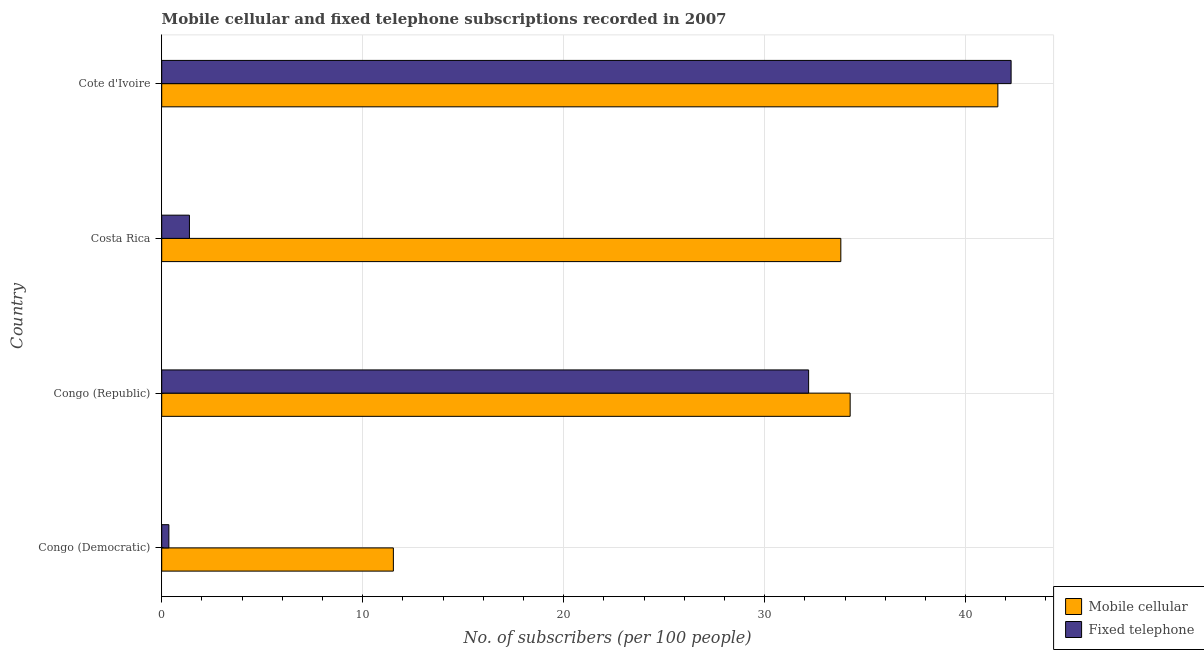How many different coloured bars are there?
Make the answer very short. 2. How many bars are there on the 3rd tick from the top?
Offer a terse response. 2. How many bars are there on the 4th tick from the bottom?
Provide a succinct answer. 2. What is the label of the 3rd group of bars from the top?
Your answer should be very brief. Congo (Republic). In how many cases, is the number of bars for a given country not equal to the number of legend labels?
Your answer should be compact. 0. What is the number of mobile cellular subscribers in Cote d'Ivoire?
Make the answer very short. 41.61. Across all countries, what is the maximum number of mobile cellular subscribers?
Make the answer very short. 41.61. Across all countries, what is the minimum number of mobile cellular subscribers?
Give a very brief answer. 11.53. In which country was the number of mobile cellular subscribers maximum?
Provide a succinct answer. Cote d'Ivoire. In which country was the number of mobile cellular subscribers minimum?
Your response must be concise. Congo (Democratic). What is the total number of fixed telephone subscribers in the graph?
Your answer should be compact. 76.19. What is the difference between the number of fixed telephone subscribers in Congo (Republic) and that in Costa Rica?
Provide a short and direct response. 30.81. What is the difference between the number of fixed telephone subscribers in Costa Rica and the number of mobile cellular subscribers in Cote d'Ivoire?
Ensure brevity in your answer.  -40.23. What is the average number of fixed telephone subscribers per country?
Your answer should be very brief. 19.05. What is the difference between the number of mobile cellular subscribers and number of fixed telephone subscribers in Cote d'Ivoire?
Your answer should be very brief. -0.66. What is the ratio of the number of mobile cellular subscribers in Congo (Republic) to that in Cote d'Ivoire?
Give a very brief answer. 0.82. Is the number of mobile cellular subscribers in Congo (Democratic) less than that in Costa Rica?
Give a very brief answer. Yes. Is the difference between the number of mobile cellular subscribers in Congo (Democratic) and Cote d'Ivoire greater than the difference between the number of fixed telephone subscribers in Congo (Democratic) and Cote d'Ivoire?
Provide a short and direct response. Yes. What is the difference between the highest and the second highest number of fixed telephone subscribers?
Your answer should be very brief. 10.07. What is the difference between the highest and the lowest number of mobile cellular subscribers?
Offer a terse response. 30.08. In how many countries, is the number of fixed telephone subscribers greater than the average number of fixed telephone subscribers taken over all countries?
Keep it short and to the point. 2. Is the sum of the number of fixed telephone subscribers in Costa Rica and Cote d'Ivoire greater than the maximum number of mobile cellular subscribers across all countries?
Offer a very short reply. Yes. What does the 1st bar from the top in Congo (Democratic) represents?
Offer a very short reply. Fixed telephone. What does the 2nd bar from the bottom in Congo (Democratic) represents?
Your answer should be compact. Fixed telephone. How many bars are there?
Give a very brief answer. 8. Are all the bars in the graph horizontal?
Give a very brief answer. Yes. What is the title of the graph?
Your answer should be compact. Mobile cellular and fixed telephone subscriptions recorded in 2007. Does "Investment in Telecom" appear as one of the legend labels in the graph?
Your response must be concise. No. What is the label or title of the X-axis?
Your answer should be compact. No. of subscribers (per 100 people). What is the label or title of the Y-axis?
Your response must be concise. Country. What is the No. of subscribers (per 100 people) of Mobile cellular in Congo (Democratic)?
Give a very brief answer. 11.53. What is the No. of subscribers (per 100 people) in Fixed telephone in Congo (Democratic)?
Make the answer very short. 0.36. What is the No. of subscribers (per 100 people) of Mobile cellular in Congo (Republic)?
Provide a succinct answer. 34.26. What is the No. of subscribers (per 100 people) of Fixed telephone in Congo (Republic)?
Ensure brevity in your answer.  32.19. What is the No. of subscribers (per 100 people) of Mobile cellular in Costa Rica?
Offer a very short reply. 33.79. What is the No. of subscribers (per 100 people) of Fixed telephone in Costa Rica?
Your response must be concise. 1.38. What is the No. of subscribers (per 100 people) in Mobile cellular in Cote d'Ivoire?
Make the answer very short. 41.61. What is the No. of subscribers (per 100 people) of Fixed telephone in Cote d'Ivoire?
Your answer should be very brief. 42.26. Across all countries, what is the maximum No. of subscribers (per 100 people) of Mobile cellular?
Offer a terse response. 41.61. Across all countries, what is the maximum No. of subscribers (per 100 people) in Fixed telephone?
Ensure brevity in your answer.  42.26. Across all countries, what is the minimum No. of subscribers (per 100 people) of Mobile cellular?
Your answer should be compact. 11.53. Across all countries, what is the minimum No. of subscribers (per 100 people) of Fixed telephone?
Your response must be concise. 0.36. What is the total No. of subscribers (per 100 people) in Mobile cellular in the graph?
Your answer should be compact. 121.18. What is the total No. of subscribers (per 100 people) of Fixed telephone in the graph?
Your response must be concise. 76.19. What is the difference between the No. of subscribers (per 100 people) of Mobile cellular in Congo (Democratic) and that in Congo (Republic)?
Make the answer very short. -22.73. What is the difference between the No. of subscribers (per 100 people) of Fixed telephone in Congo (Democratic) and that in Congo (Republic)?
Your response must be concise. -31.83. What is the difference between the No. of subscribers (per 100 people) of Mobile cellular in Congo (Democratic) and that in Costa Rica?
Provide a succinct answer. -22.27. What is the difference between the No. of subscribers (per 100 people) of Fixed telephone in Congo (Democratic) and that in Costa Rica?
Keep it short and to the point. -1.02. What is the difference between the No. of subscribers (per 100 people) in Mobile cellular in Congo (Democratic) and that in Cote d'Ivoire?
Your answer should be very brief. -30.08. What is the difference between the No. of subscribers (per 100 people) of Fixed telephone in Congo (Democratic) and that in Cote d'Ivoire?
Your answer should be very brief. -41.91. What is the difference between the No. of subscribers (per 100 people) in Mobile cellular in Congo (Republic) and that in Costa Rica?
Offer a terse response. 0.46. What is the difference between the No. of subscribers (per 100 people) in Fixed telephone in Congo (Republic) and that in Costa Rica?
Your answer should be very brief. 30.81. What is the difference between the No. of subscribers (per 100 people) of Mobile cellular in Congo (Republic) and that in Cote d'Ivoire?
Offer a very short reply. -7.35. What is the difference between the No. of subscribers (per 100 people) of Fixed telephone in Congo (Republic) and that in Cote d'Ivoire?
Keep it short and to the point. -10.08. What is the difference between the No. of subscribers (per 100 people) of Mobile cellular in Costa Rica and that in Cote d'Ivoire?
Provide a short and direct response. -7.81. What is the difference between the No. of subscribers (per 100 people) in Fixed telephone in Costa Rica and that in Cote d'Ivoire?
Your answer should be very brief. -40.89. What is the difference between the No. of subscribers (per 100 people) in Mobile cellular in Congo (Democratic) and the No. of subscribers (per 100 people) in Fixed telephone in Congo (Republic)?
Your answer should be compact. -20.66. What is the difference between the No. of subscribers (per 100 people) of Mobile cellular in Congo (Democratic) and the No. of subscribers (per 100 people) of Fixed telephone in Costa Rica?
Offer a terse response. 10.15. What is the difference between the No. of subscribers (per 100 people) of Mobile cellular in Congo (Democratic) and the No. of subscribers (per 100 people) of Fixed telephone in Cote d'Ivoire?
Your response must be concise. -30.74. What is the difference between the No. of subscribers (per 100 people) in Mobile cellular in Congo (Republic) and the No. of subscribers (per 100 people) in Fixed telephone in Costa Rica?
Offer a very short reply. 32.88. What is the difference between the No. of subscribers (per 100 people) of Mobile cellular in Congo (Republic) and the No. of subscribers (per 100 people) of Fixed telephone in Cote d'Ivoire?
Ensure brevity in your answer.  -8.01. What is the difference between the No. of subscribers (per 100 people) of Mobile cellular in Costa Rica and the No. of subscribers (per 100 people) of Fixed telephone in Cote d'Ivoire?
Provide a succinct answer. -8.47. What is the average No. of subscribers (per 100 people) of Mobile cellular per country?
Make the answer very short. 30.3. What is the average No. of subscribers (per 100 people) of Fixed telephone per country?
Ensure brevity in your answer.  19.05. What is the difference between the No. of subscribers (per 100 people) of Mobile cellular and No. of subscribers (per 100 people) of Fixed telephone in Congo (Democratic)?
Give a very brief answer. 11.17. What is the difference between the No. of subscribers (per 100 people) of Mobile cellular and No. of subscribers (per 100 people) of Fixed telephone in Congo (Republic)?
Your answer should be compact. 2.07. What is the difference between the No. of subscribers (per 100 people) of Mobile cellular and No. of subscribers (per 100 people) of Fixed telephone in Costa Rica?
Provide a short and direct response. 32.41. What is the difference between the No. of subscribers (per 100 people) in Mobile cellular and No. of subscribers (per 100 people) in Fixed telephone in Cote d'Ivoire?
Make the answer very short. -0.66. What is the ratio of the No. of subscribers (per 100 people) in Mobile cellular in Congo (Democratic) to that in Congo (Republic)?
Keep it short and to the point. 0.34. What is the ratio of the No. of subscribers (per 100 people) in Fixed telephone in Congo (Democratic) to that in Congo (Republic)?
Your answer should be very brief. 0.01. What is the ratio of the No. of subscribers (per 100 people) of Mobile cellular in Congo (Democratic) to that in Costa Rica?
Your answer should be compact. 0.34. What is the ratio of the No. of subscribers (per 100 people) in Fixed telephone in Congo (Democratic) to that in Costa Rica?
Make the answer very short. 0.26. What is the ratio of the No. of subscribers (per 100 people) in Mobile cellular in Congo (Democratic) to that in Cote d'Ivoire?
Make the answer very short. 0.28. What is the ratio of the No. of subscribers (per 100 people) in Fixed telephone in Congo (Democratic) to that in Cote d'Ivoire?
Your answer should be compact. 0.01. What is the ratio of the No. of subscribers (per 100 people) of Mobile cellular in Congo (Republic) to that in Costa Rica?
Your response must be concise. 1.01. What is the ratio of the No. of subscribers (per 100 people) in Fixed telephone in Congo (Republic) to that in Costa Rica?
Make the answer very short. 23.34. What is the ratio of the No. of subscribers (per 100 people) of Mobile cellular in Congo (Republic) to that in Cote d'Ivoire?
Provide a succinct answer. 0.82. What is the ratio of the No. of subscribers (per 100 people) in Fixed telephone in Congo (Republic) to that in Cote d'Ivoire?
Provide a succinct answer. 0.76. What is the ratio of the No. of subscribers (per 100 people) of Mobile cellular in Costa Rica to that in Cote d'Ivoire?
Offer a very short reply. 0.81. What is the ratio of the No. of subscribers (per 100 people) of Fixed telephone in Costa Rica to that in Cote d'Ivoire?
Your answer should be very brief. 0.03. What is the difference between the highest and the second highest No. of subscribers (per 100 people) in Mobile cellular?
Ensure brevity in your answer.  7.35. What is the difference between the highest and the second highest No. of subscribers (per 100 people) of Fixed telephone?
Your response must be concise. 10.08. What is the difference between the highest and the lowest No. of subscribers (per 100 people) of Mobile cellular?
Keep it short and to the point. 30.08. What is the difference between the highest and the lowest No. of subscribers (per 100 people) in Fixed telephone?
Offer a terse response. 41.91. 